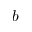Convert formula to latex. <formula><loc_0><loc_0><loc_500><loc_500>b</formula> 